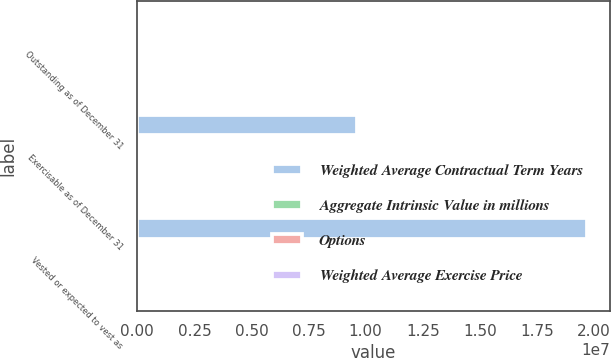Convert chart to OTSL. <chart><loc_0><loc_0><loc_500><loc_500><stacked_bar_chart><ecel><fcel>Outstanding as of December 31<fcel>Exercisable as of December 31<fcel>Vested or expected to vest as<nl><fcel>Weighted Average Contractual Term Years<fcel>19.67<fcel>9.64034e+06<fcel>1.97148e+07<nl><fcel>Aggregate Intrinsic Value in millions<fcel>19.67<fcel>15.14<fcel>19.46<nl><fcel>Options<fcel>6.84<fcel>4.95<fcel>6.77<nl><fcel>Weighted Average Exercise Price<fcel>362.5<fcel>216.1<fcel>354<nl></chart> 